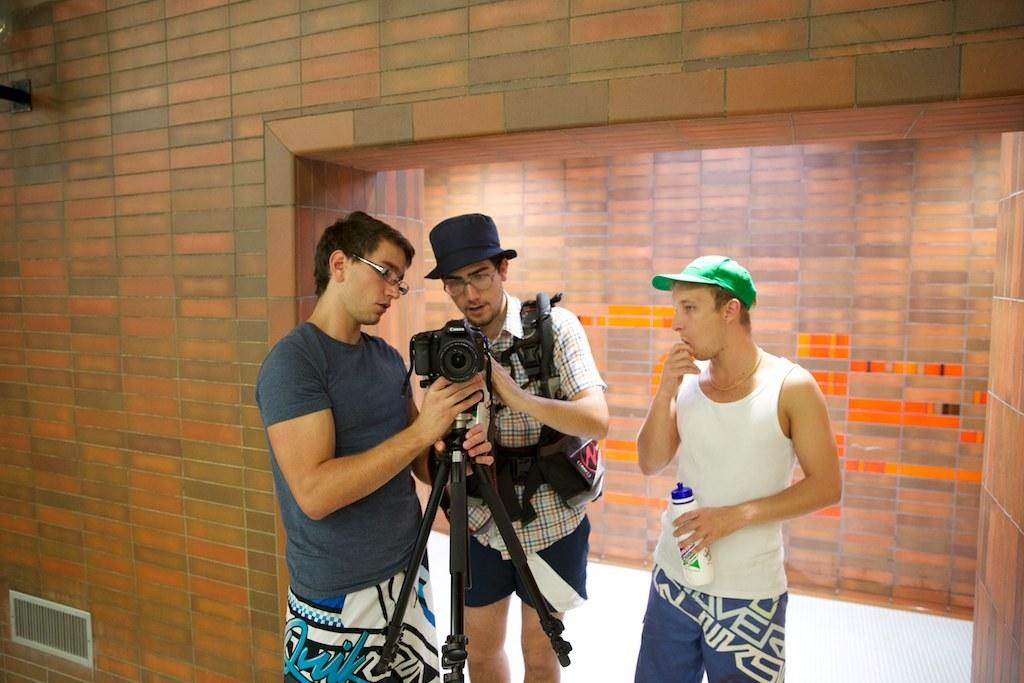How many people are in the image? There are three men in the image. What are the men doing in the image? The men are standing and looking at a camera. What are two of the men wearing on their heads? Two of the men are wearing caps. What is the background of the image? There is a brick wall behind the men. What scent can be detected from the ducks in the image? There are no ducks present in the image, so no scent can be detected from them. 